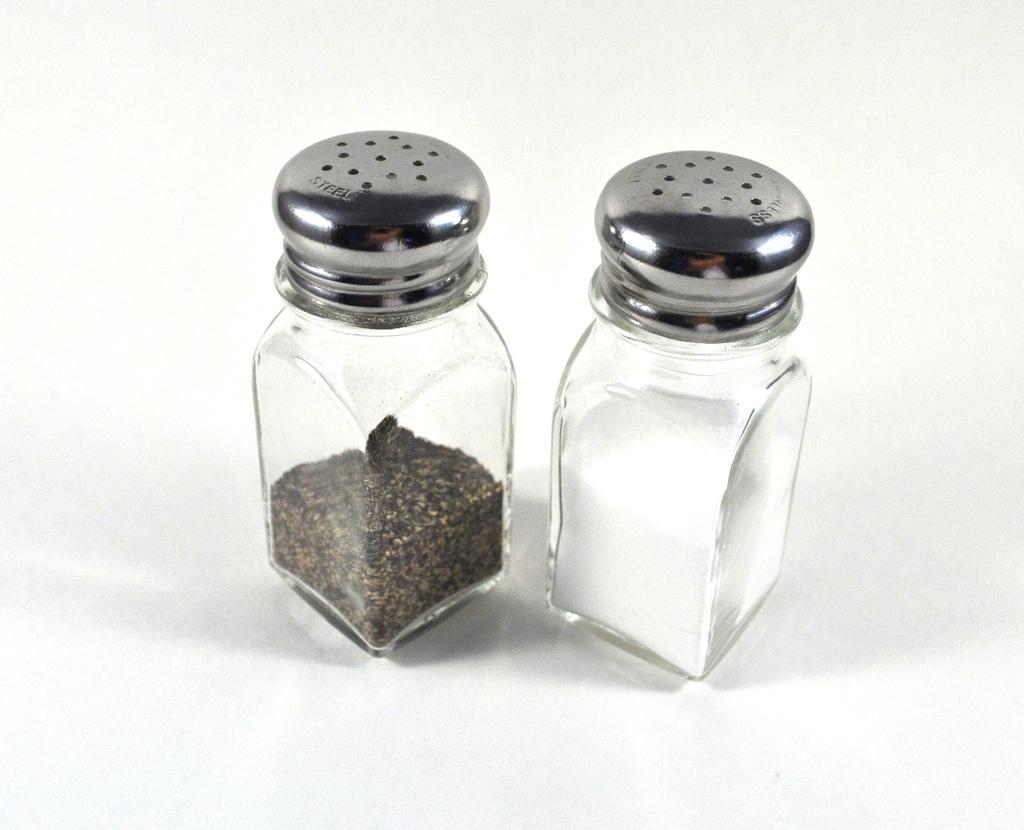Please provide a concise description of this image. Here we can see two jars with powders on this white surface. 